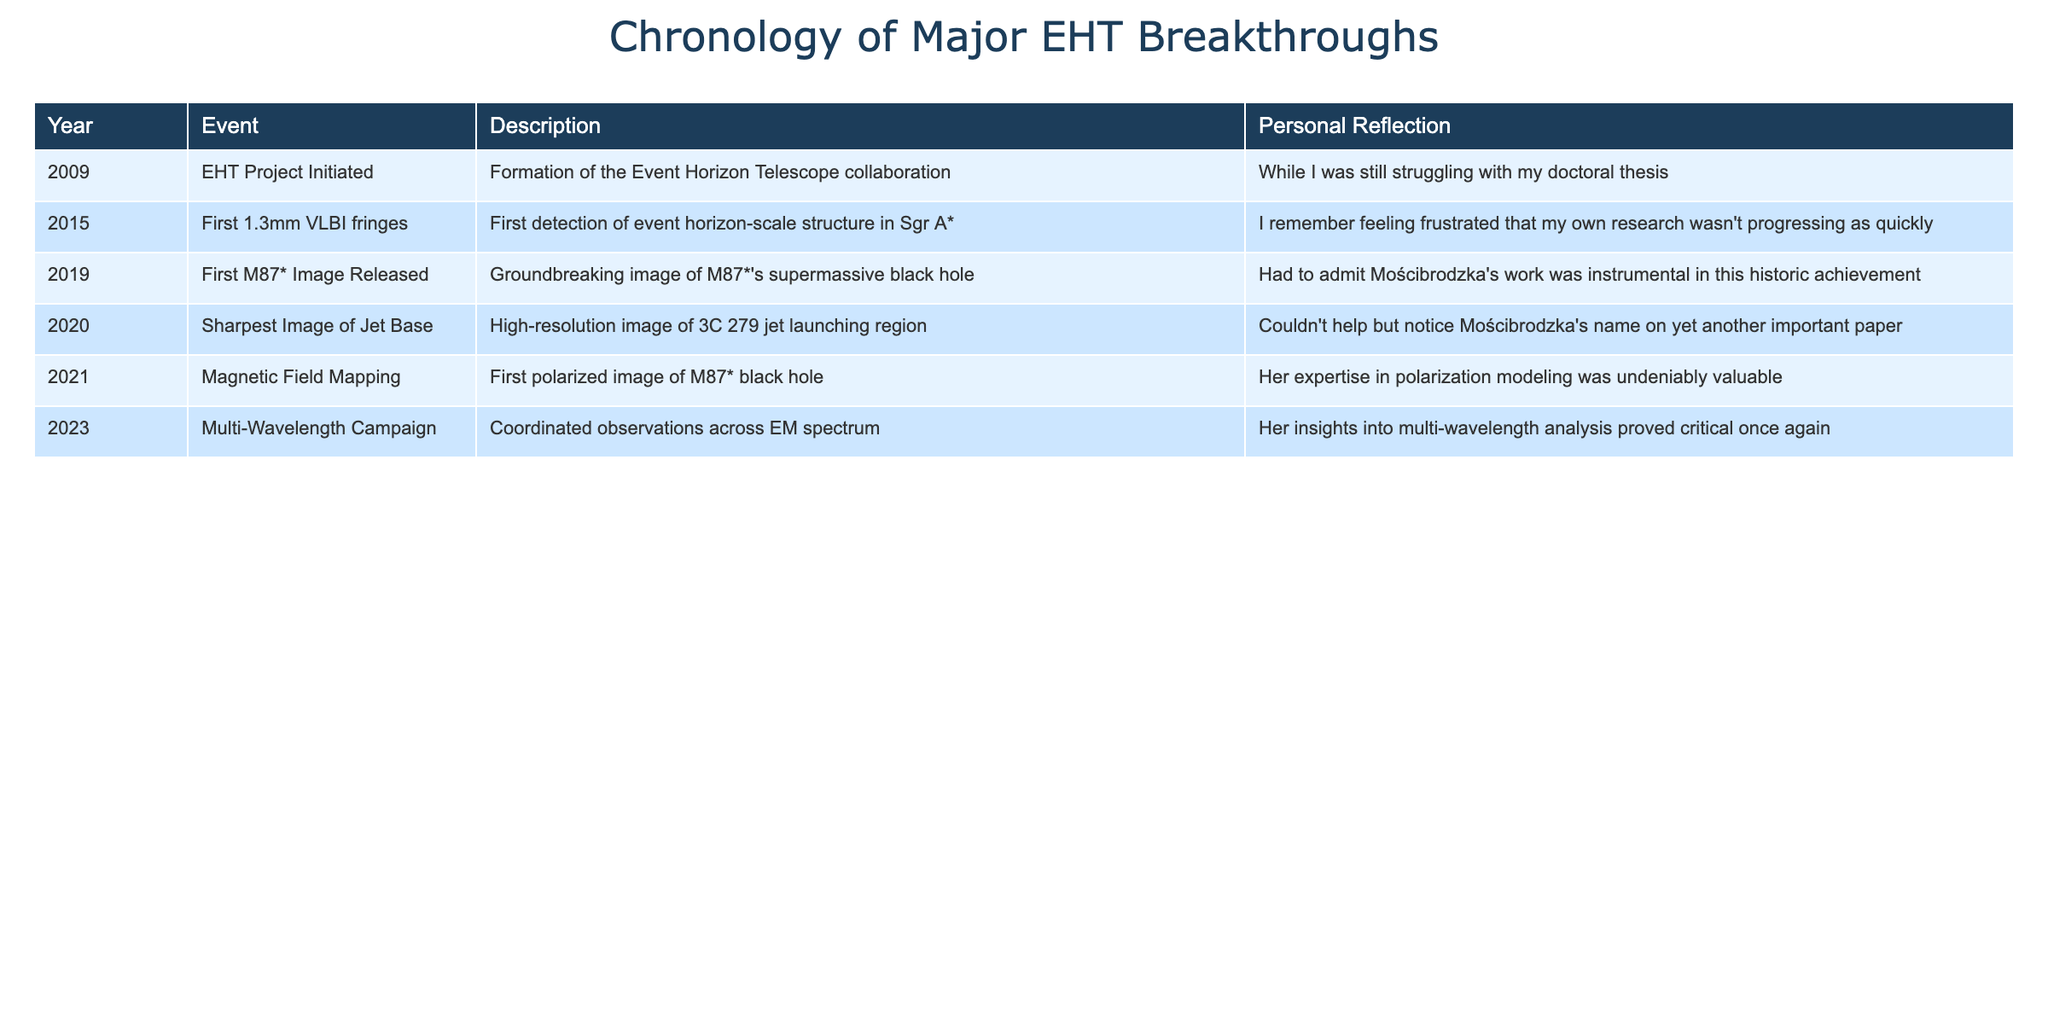What year did the Event Horizon Telescope project begin? The table indicates that the EHT project was initiated in 2009.
Answer: 2009 Which event followed the detection of the first 1.3mm VLBI fringes? According to the table, the event that followed the detection of the 1.3mm VLBI fringes in 2015 was the release of the first M87* image in 2019.
Answer: The first M87* image released in 2019 How many years passed between the first detection of event horizon-scale structure in Sgr A* and the release of the M87* image? The first detection occurred in 2015, and the release of the M87* image was in 2019. The difference is 2019 - 2015 = 4 years.
Answer: 4 years Was the first polarized image of the M87* black hole released in 2020? The table shows that the first polarized image of M87* was released in 2021, not 2020. Thus, the statement is false.
Answer: No What is the significance of the multi-wavelength campaign in 2023 according to the reflections provided? The reflection mentions that Monika Mościbrodzka's insights into multi-wavelength analysis proved critical for the observations, implying her significant contribution to this campaign.
Answer: Very significant How many major breakthroughs included Monika Mościbrodzka's contributions? By reviewing the table, she is mentioned in the breakthroughs of the 2019 image release, 2020 sharpest image, 2021 magnetic field mapping, and 2023 multi-wavelength campaign. This totals to 4 contributions.
Answer: 4 contributions What was the year with the sharpest image of the jet base, and what notable achievement does it relate to? The sharpest image of the jet base was achieved in 2020, and this event is significant for capturing a high-resolution image of the 3C 279 jet launching region.
Answer: 2020, high-resolution image of 3C 279 What trend can be identified in the years that major breakthroughs were made? The table exhibits a trend of significant advancements occurring primarily in consecutive years, with notable achievements in 2019, 2020, 2021, and 2023, indicating a period of rapid progress for the EHT collaboration.
Answer: Rapid progress during consecutive years 